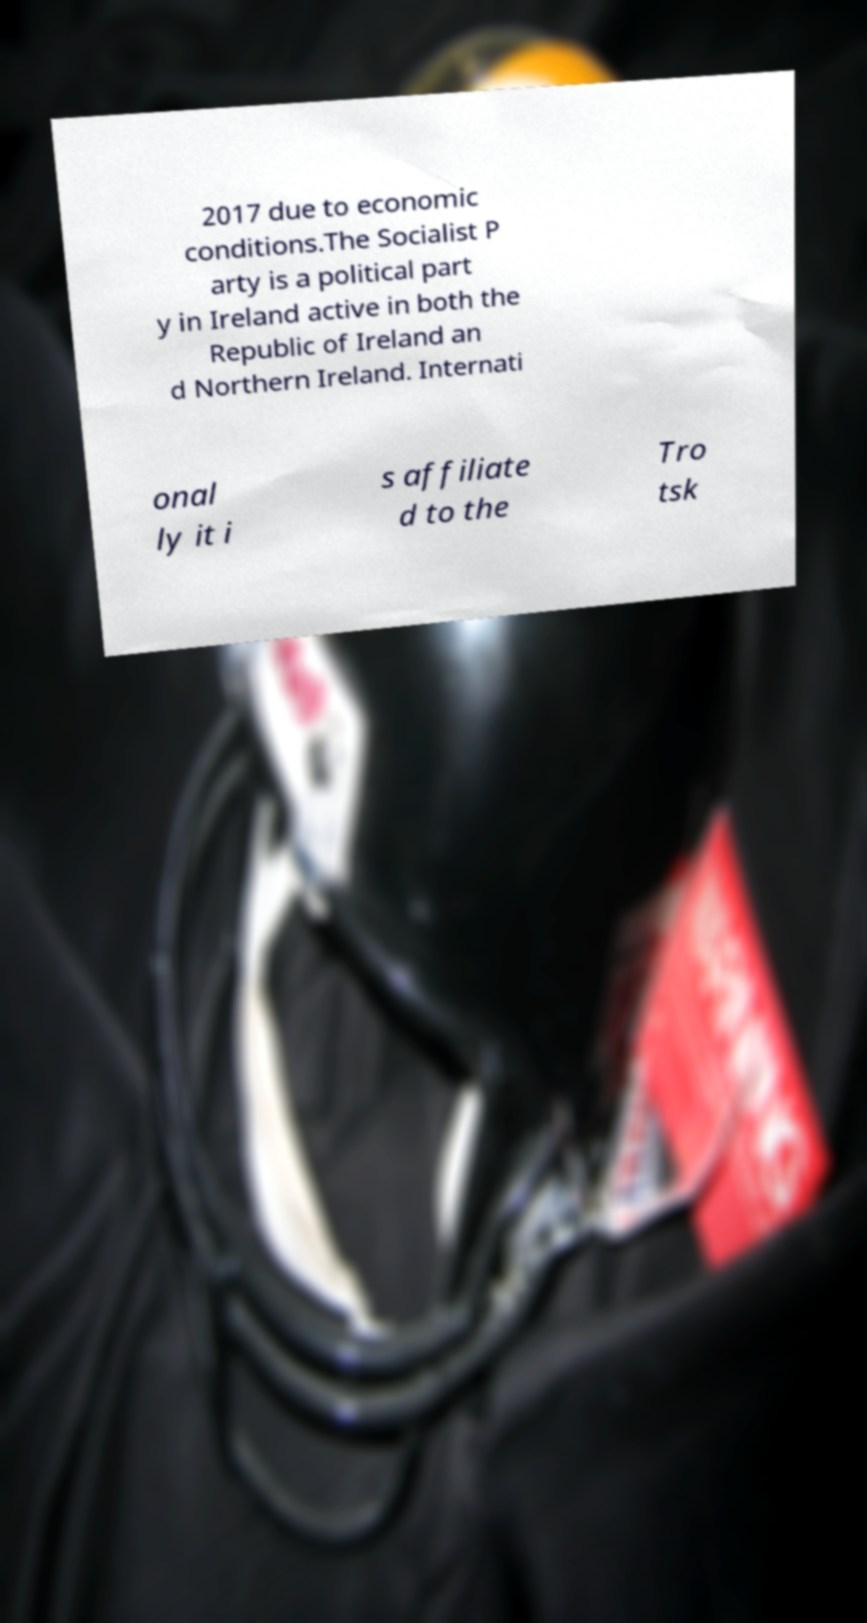Could you assist in decoding the text presented in this image and type it out clearly? 2017 due to economic conditions.The Socialist P arty is a political part y in Ireland active in both the Republic of Ireland an d Northern Ireland. Internati onal ly it i s affiliate d to the Tro tsk 